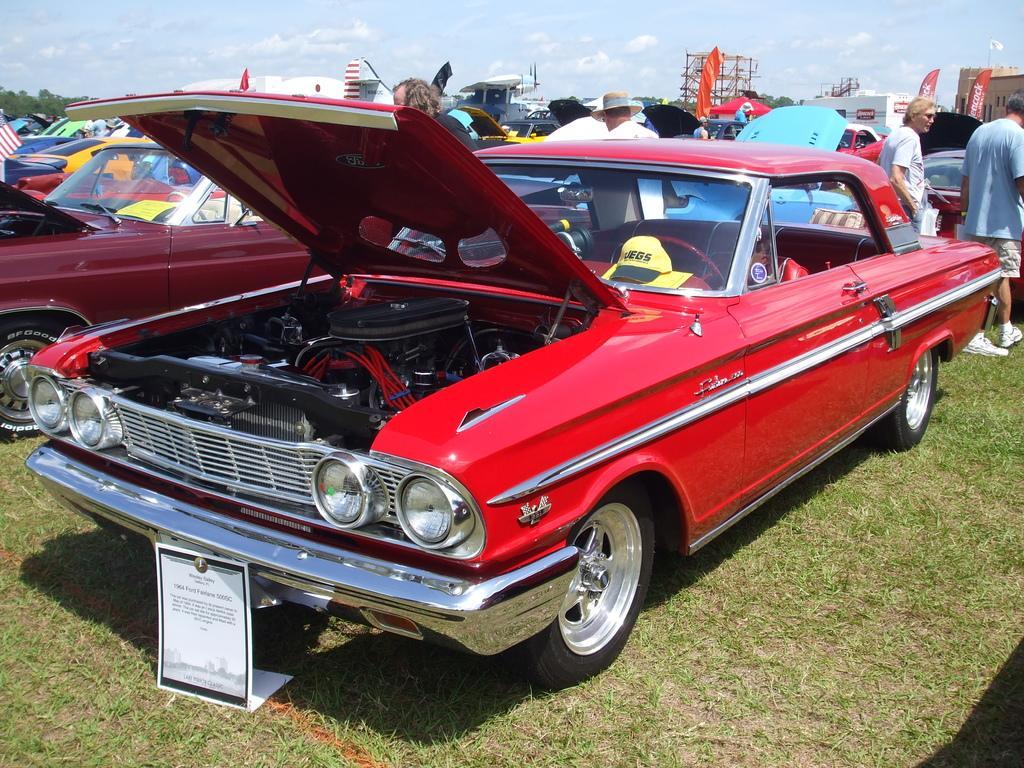Please provide a concise description of this image. In this image there are many cars. Here there is a board. In the background there are many people, trees. The sky is cloudy. 